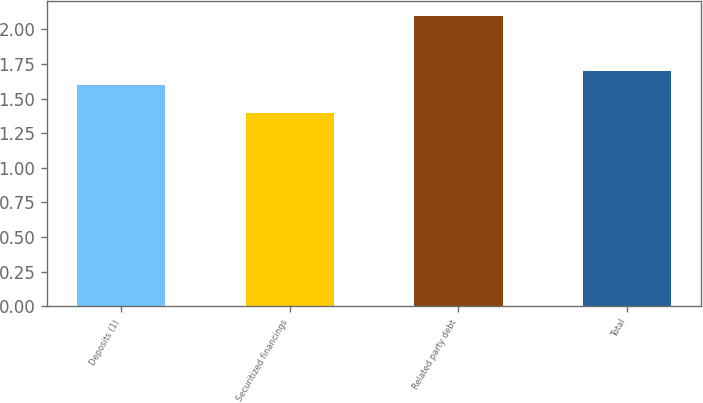<chart> <loc_0><loc_0><loc_500><loc_500><bar_chart><fcel>Deposits (1)<fcel>Securitized financings<fcel>Related party debt<fcel>Total<nl><fcel>1.6<fcel>1.4<fcel>2.1<fcel>1.7<nl></chart> 